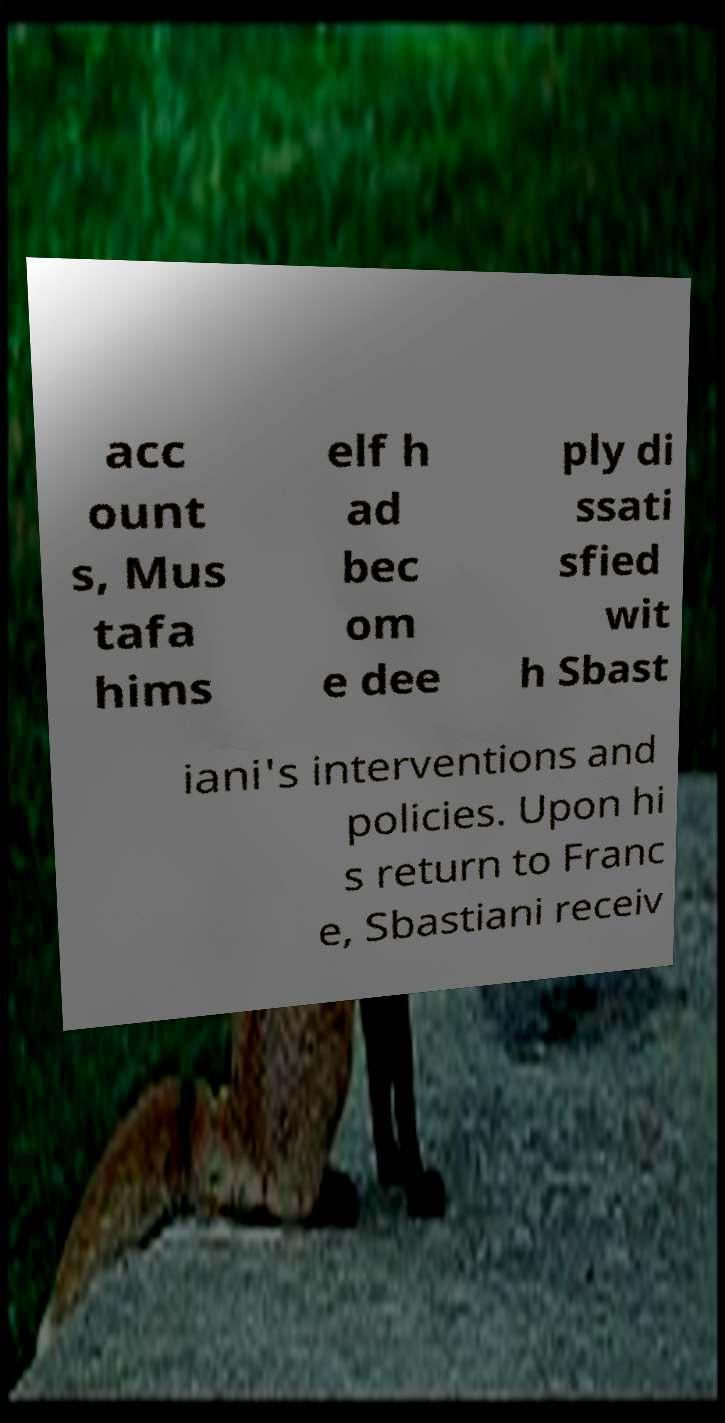Can you accurately transcribe the text from the provided image for me? acc ount s, Mus tafa hims elf h ad bec om e dee ply di ssati sfied wit h Sbast iani's interventions and policies. Upon hi s return to Franc e, Sbastiani receiv 